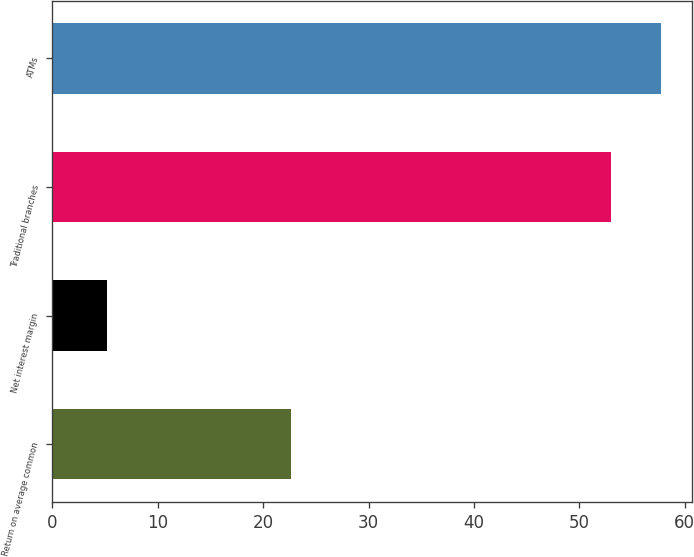<chart> <loc_0><loc_0><loc_500><loc_500><bar_chart><fcel>Return on average common<fcel>Net interest margin<fcel>Traditional branches<fcel>ATMs<nl><fcel>22.62<fcel>5.23<fcel>53<fcel>57.78<nl></chart> 